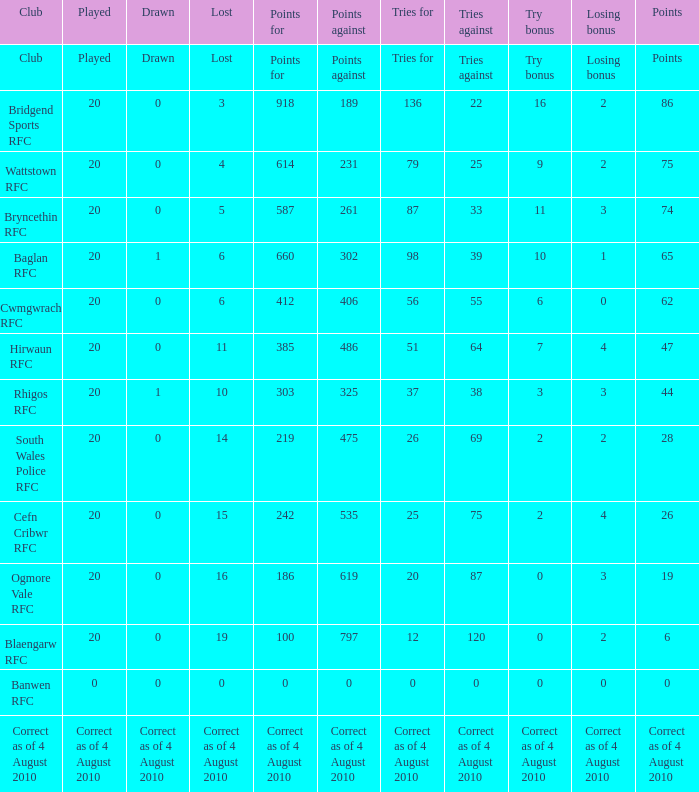In the context of tries fow, what is the consequence of losing the bonus when the bonus is lost? Tries for. 